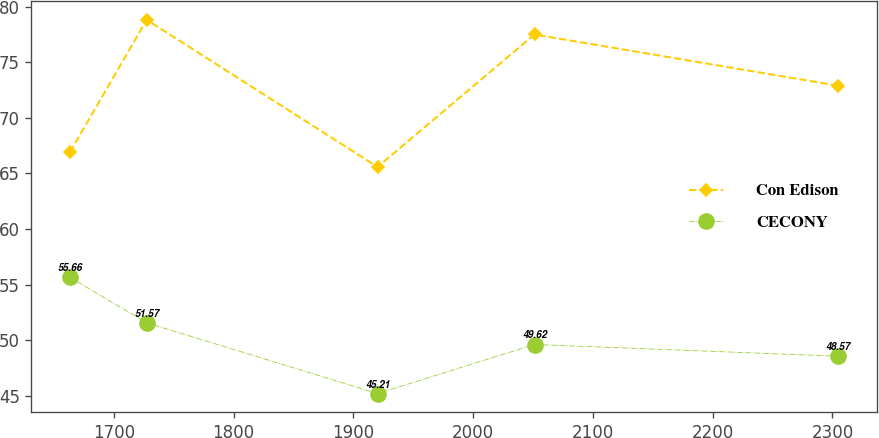<chart> <loc_0><loc_0><loc_500><loc_500><line_chart><ecel><fcel>Con Edison<fcel>CECONY<nl><fcel>1663.24<fcel>66.9<fcel>55.66<nl><fcel>1727.41<fcel>78.81<fcel>51.57<nl><fcel>1920.13<fcel>65.58<fcel>45.21<nl><fcel>2051.21<fcel>77.49<fcel>49.62<nl><fcel>2304.9<fcel>72.88<fcel>48.57<nl></chart> 